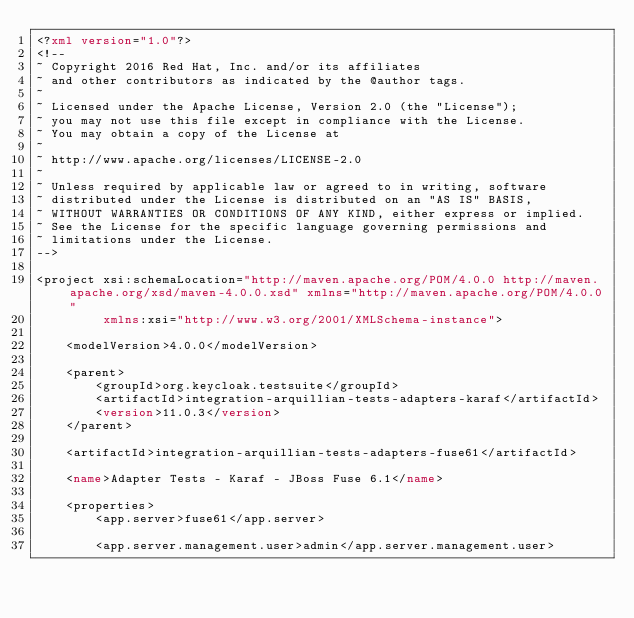<code> <loc_0><loc_0><loc_500><loc_500><_XML_><?xml version="1.0"?>
<!--
~ Copyright 2016 Red Hat, Inc. and/or its affiliates
~ and other contributors as indicated by the @author tags.
~
~ Licensed under the Apache License, Version 2.0 (the "License");
~ you may not use this file except in compliance with the License.
~ You may obtain a copy of the License at
~
~ http://www.apache.org/licenses/LICENSE-2.0
~
~ Unless required by applicable law or agreed to in writing, software
~ distributed under the License is distributed on an "AS IS" BASIS,
~ WITHOUT WARRANTIES OR CONDITIONS OF ANY KIND, either express or implied.
~ See the License for the specific language governing permissions and
~ limitations under the License.
-->

<project xsi:schemaLocation="http://maven.apache.org/POM/4.0.0 http://maven.apache.org/xsd/maven-4.0.0.xsd" xmlns="http://maven.apache.org/POM/4.0.0"
         xmlns:xsi="http://www.w3.org/2001/XMLSchema-instance">

    <modelVersion>4.0.0</modelVersion>

    <parent>
        <groupId>org.keycloak.testsuite</groupId>
        <artifactId>integration-arquillian-tests-adapters-karaf</artifactId>
        <version>11.0.3</version>
    </parent>

    <artifactId>integration-arquillian-tests-adapters-fuse61</artifactId>

    <name>Adapter Tests - Karaf - JBoss Fuse 6.1</name>
        
    <properties>
        <app.server>fuse61</app.server>

        <app.server.management.user>admin</app.server.management.user></code> 